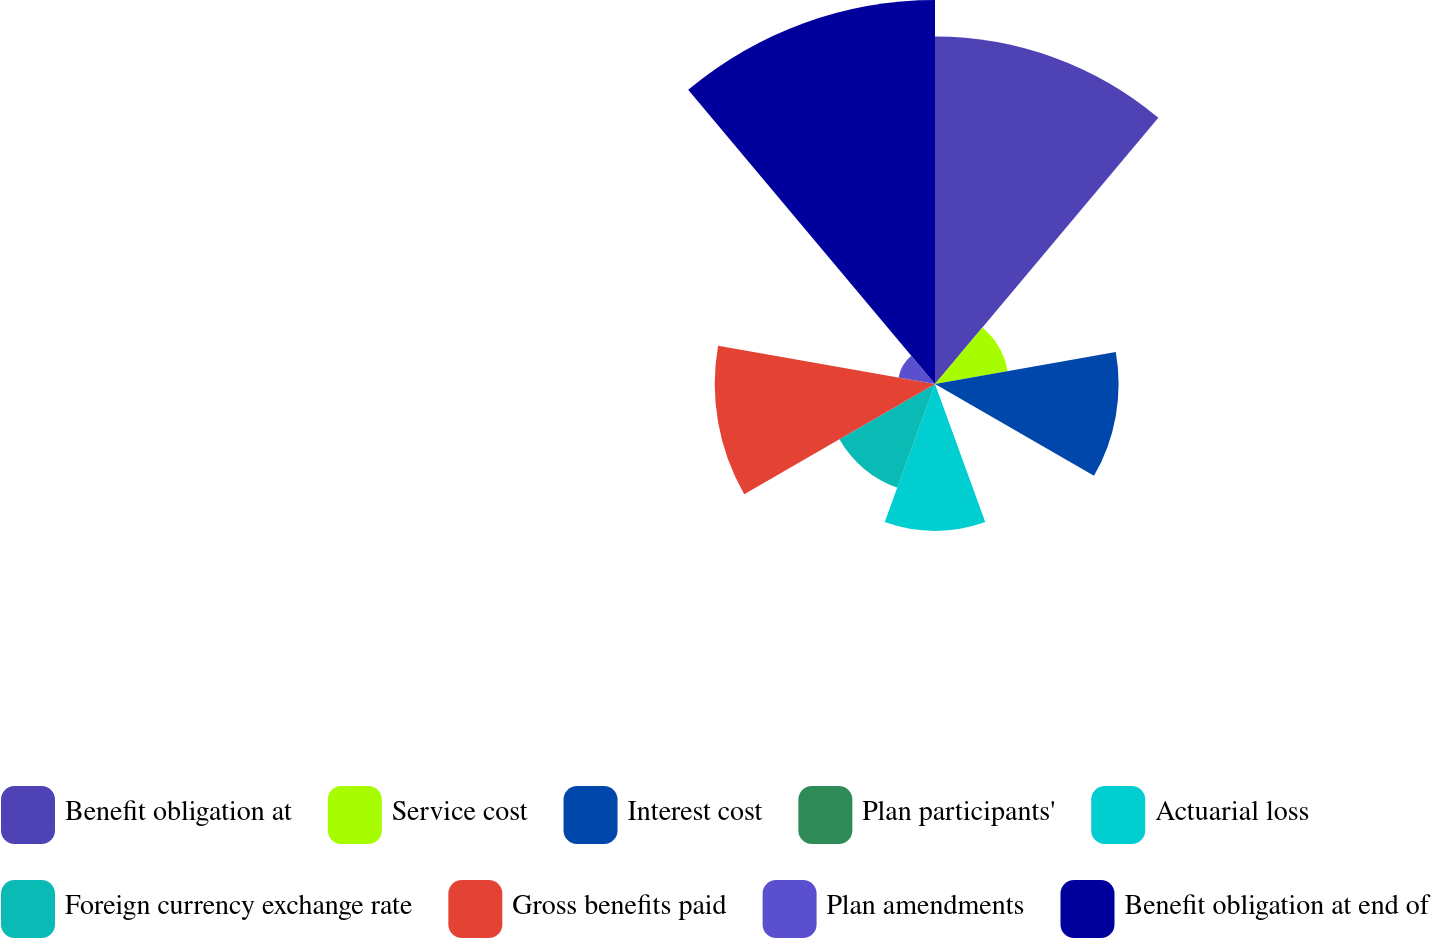Convert chart to OTSL. <chart><loc_0><loc_0><loc_500><loc_500><pie_chart><fcel>Benefit obligation at<fcel>Service cost<fcel>Interest cost<fcel>Plan participants'<fcel>Actuarial loss<fcel>Foreign currency exchange rate<fcel>Gross benefits paid<fcel>Plan amendments<fcel>Benefit obligation at end of<nl><fcel>23.11%<fcel>4.9%<fcel>12.21%<fcel>0.02%<fcel>9.77%<fcel>7.34%<fcel>14.65%<fcel>2.46%<fcel>25.54%<nl></chart> 